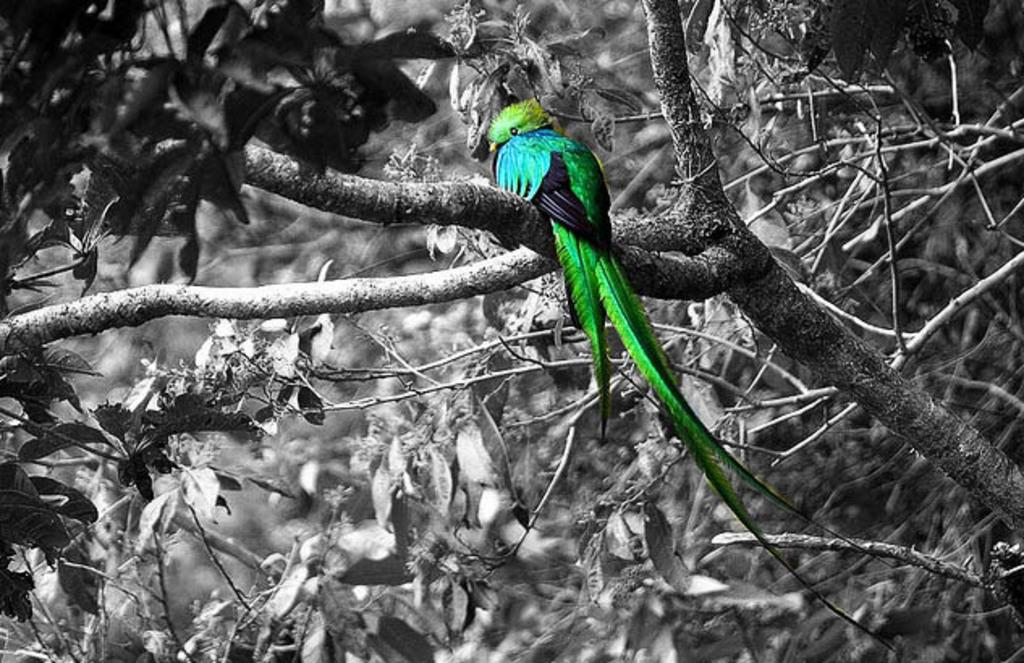What is the color scheme of the image? The image is black and white. What type of animal can be seen in the image? There is a bird in the image. Where is the bird located in the image? The bird is on a branch of a tree. Can you describe the background of the image? The background of the image is not clear enough to describe. What type of spy equipment can be seen in the image? There is no spy equipment present in the image; it features a bird on a tree branch. What kind of silver object is visible in the image? There is no silver object present in the image. 